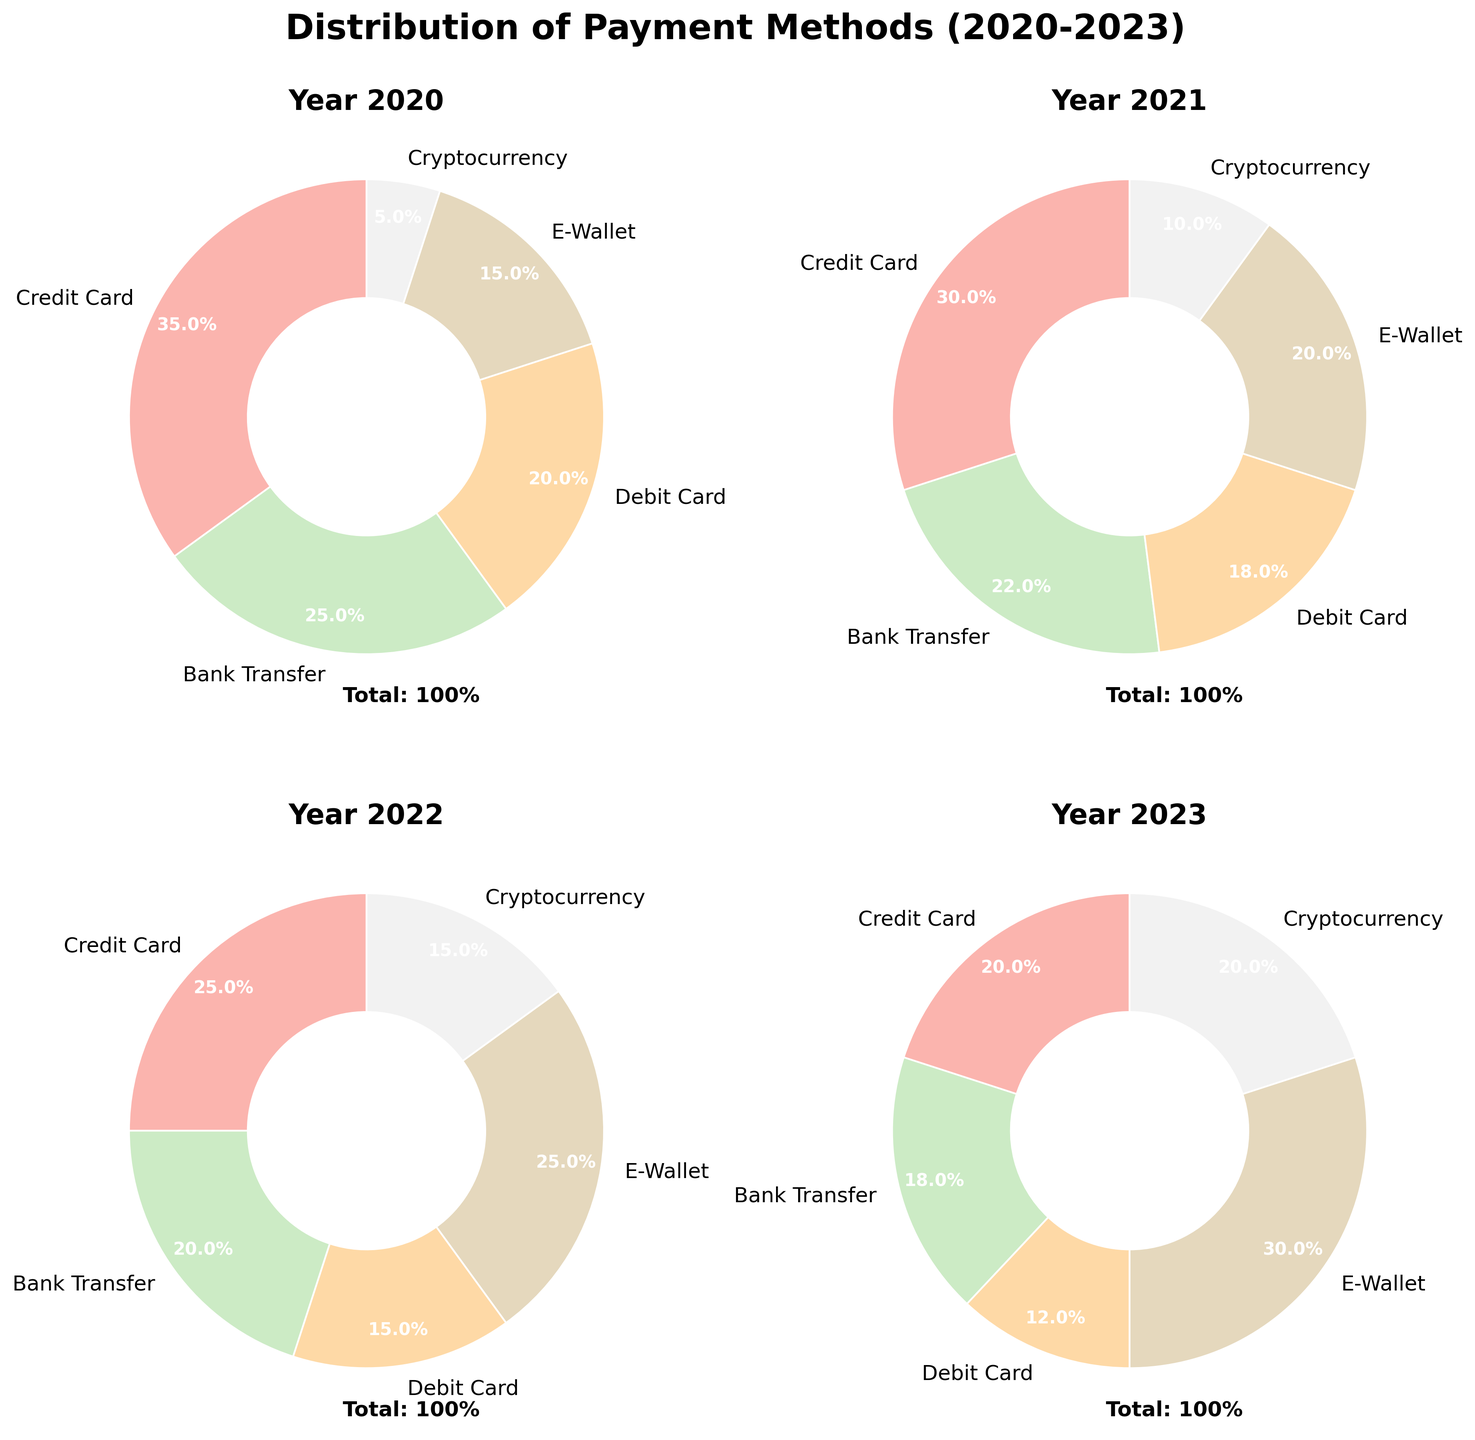Which year had the highest percentage of Credit Card use? By observing the percentages in the pie charts for each year (2020-2023), we can see that 2020 had the highest percentage of Credit Card use at 35%.
Answer: 2020 How has the usage of E-Wallets changed from 2020 to 2023? Looking at the pie charts, E-Wallets usage increased from 15% in 2020 to 30% in 2023.
Answer: Increased In which year was Cryptocurrency usage the same as E-Wallet usage? In 2023, both Cryptocurrency and E-Wallet usage were at 20%.
Answer: 2023 Compare the percentage of Debit Card usage between 2020 and 2021. From the charts, Debit Card usage was 20% in 2020 and decreased to 18% in 2021.
Answer: Decreased What is the sum of Bank Transfer and Debit Card usage percentages for 2022? For 2022, Bank Transfer is 20% and Debit Card is 15%. Summing them gives 20% + 15% = 35%.
Answer: 35% Which payment method showed the most significant growth from 2020 to 2023? E-Wallet usage grew from 15% in 2020 to 30% in 2023, which is the most significant increase among the methods.
Answer: E-Wallet Which year had the lowest usage of Debit Cards? By checking the pie charts, 2023 had the lowest Debit Card usage at 12%.
Answer: 2023 In 2021, which payment method had the highest percentage and what was it? In 2021, the method with the highest percentage was Credit Card at 30%.
Answer: Credit Card, 30% What was the change in percentage points for Cryptocurrency usage from 2020 to 2023? Cryptocurrency usage increased from 5% in 2020 to 20% in 2023. The change is 20% - 5% = 15 percentage points.
Answer: 15 percentage points Which year had the least variation in the usage of different payment methods? 2022 had more evenly distributed percentages among the payment methods compared to other years. The variations across categories seem smaller visually.
Answer: 2022 